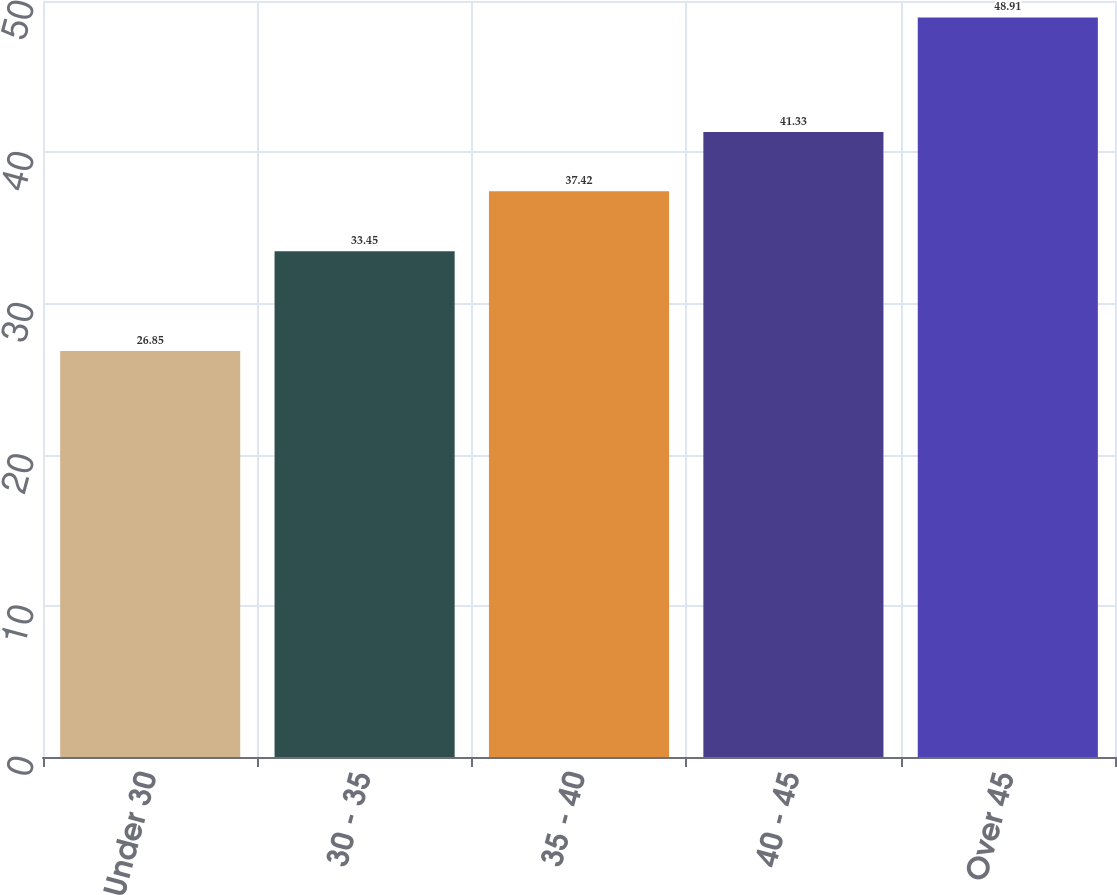Convert chart to OTSL. <chart><loc_0><loc_0><loc_500><loc_500><bar_chart><fcel>Under 30<fcel>30 - 35<fcel>35 - 40<fcel>40 - 45<fcel>Over 45<nl><fcel>26.85<fcel>33.45<fcel>37.42<fcel>41.33<fcel>48.91<nl></chart> 